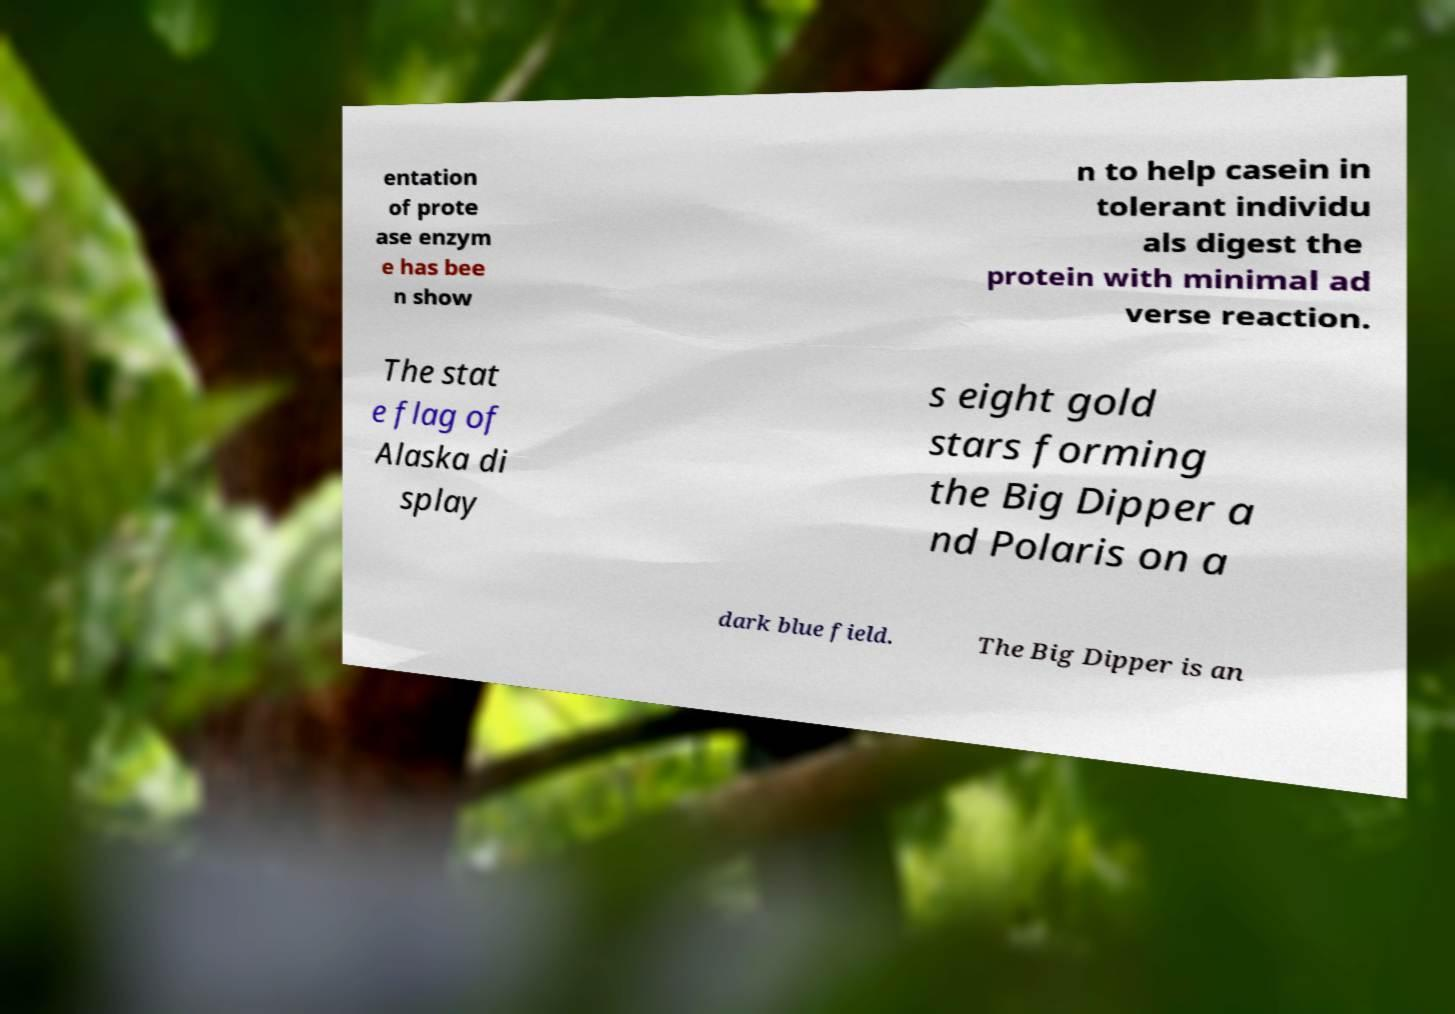Could you assist in decoding the text presented in this image and type it out clearly? entation of prote ase enzym e has bee n show n to help casein in tolerant individu als digest the protein with minimal ad verse reaction. The stat e flag of Alaska di splay s eight gold stars forming the Big Dipper a nd Polaris on a dark blue field. The Big Dipper is an 